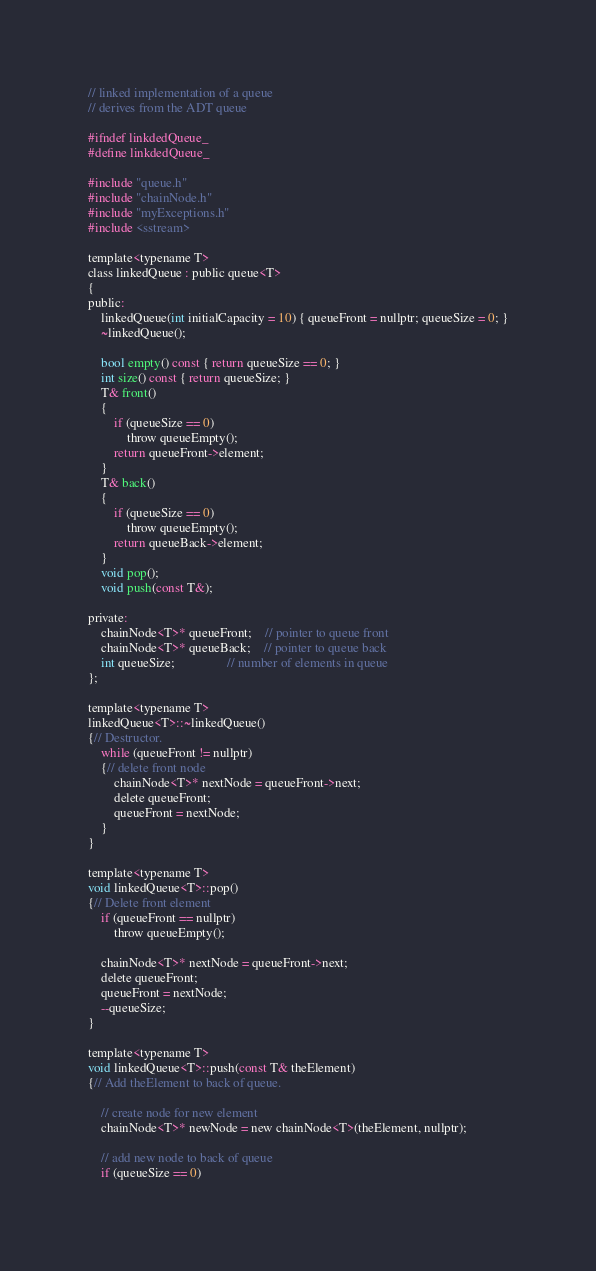Convert code to text. <code><loc_0><loc_0><loc_500><loc_500><_C_>
// linked implementation of a queue
// derives from the ADT queue

#ifndef linkdedQueue_
#define linkdedQueue_

#include "queue.h"
#include "chainNode.h"
#include "myExceptions.h"
#include <sstream>

template<typename T>
class linkedQueue : public queue<T>
{
public:
	linkedQueue(int initialCapacity = 10) { queueFront = nullptr; queueSize = 0; }
	~linkedQueue();

	bool empty() const { return queueSize == 0; }
	int size() const { return queueSize; }
	T& front()
	{
		if (queueSize == 0)
			throw queueEmpty();
		return queueFront->element;
	}
	T& back()
	{
		if (queueSize == 0)
			throw queueEmpty();
		return queueBack->element;
	}
	void pop();
	void push(const T&);

private:
	chainNode<T>* queueFront;	// pointer to queue front
	chainNode<T>* queueBack;	// pointer to queue back
	int queueSize;				// number of elements in queue
};

template<typename T>
linkedQueue<T>::~linkedQueue()
{// Destructor.
	while (queueFront != nullptr)
	{// delete front node
		chainNode<T>* nextNode = queueFront->next;
		delete queueFront;
		queueFront = nextNode;
	}
}

template<typename T>
void linkedQueue<T>::pop()
{// Delete front element
	if (queueFront == nullptr)
		throw queueEmpty();

	chainNode<T>* nextNode = queueFront->next;
	delete queueFront;
	queueFront = nextNode;
	--queueSize;
}

template<typename T>
void linkedQueue<T>::push(const T& theElement)
{// Add theElement to back of queue.

	// create node for new element
	chainNode<T>* newNode = new chainNode<T>(theElement, nullptr);

	// add new node to back of queue
	if (queueSize == 0)</code> 